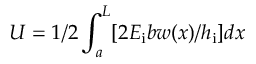<formula> <loc_0><loc_0><loc_500><loc_500>U = 1 / 2 \int _ { a } ^ { L } [ 2 E _ { i } b w ( x ) / h _ { i } ] d x</formula> 